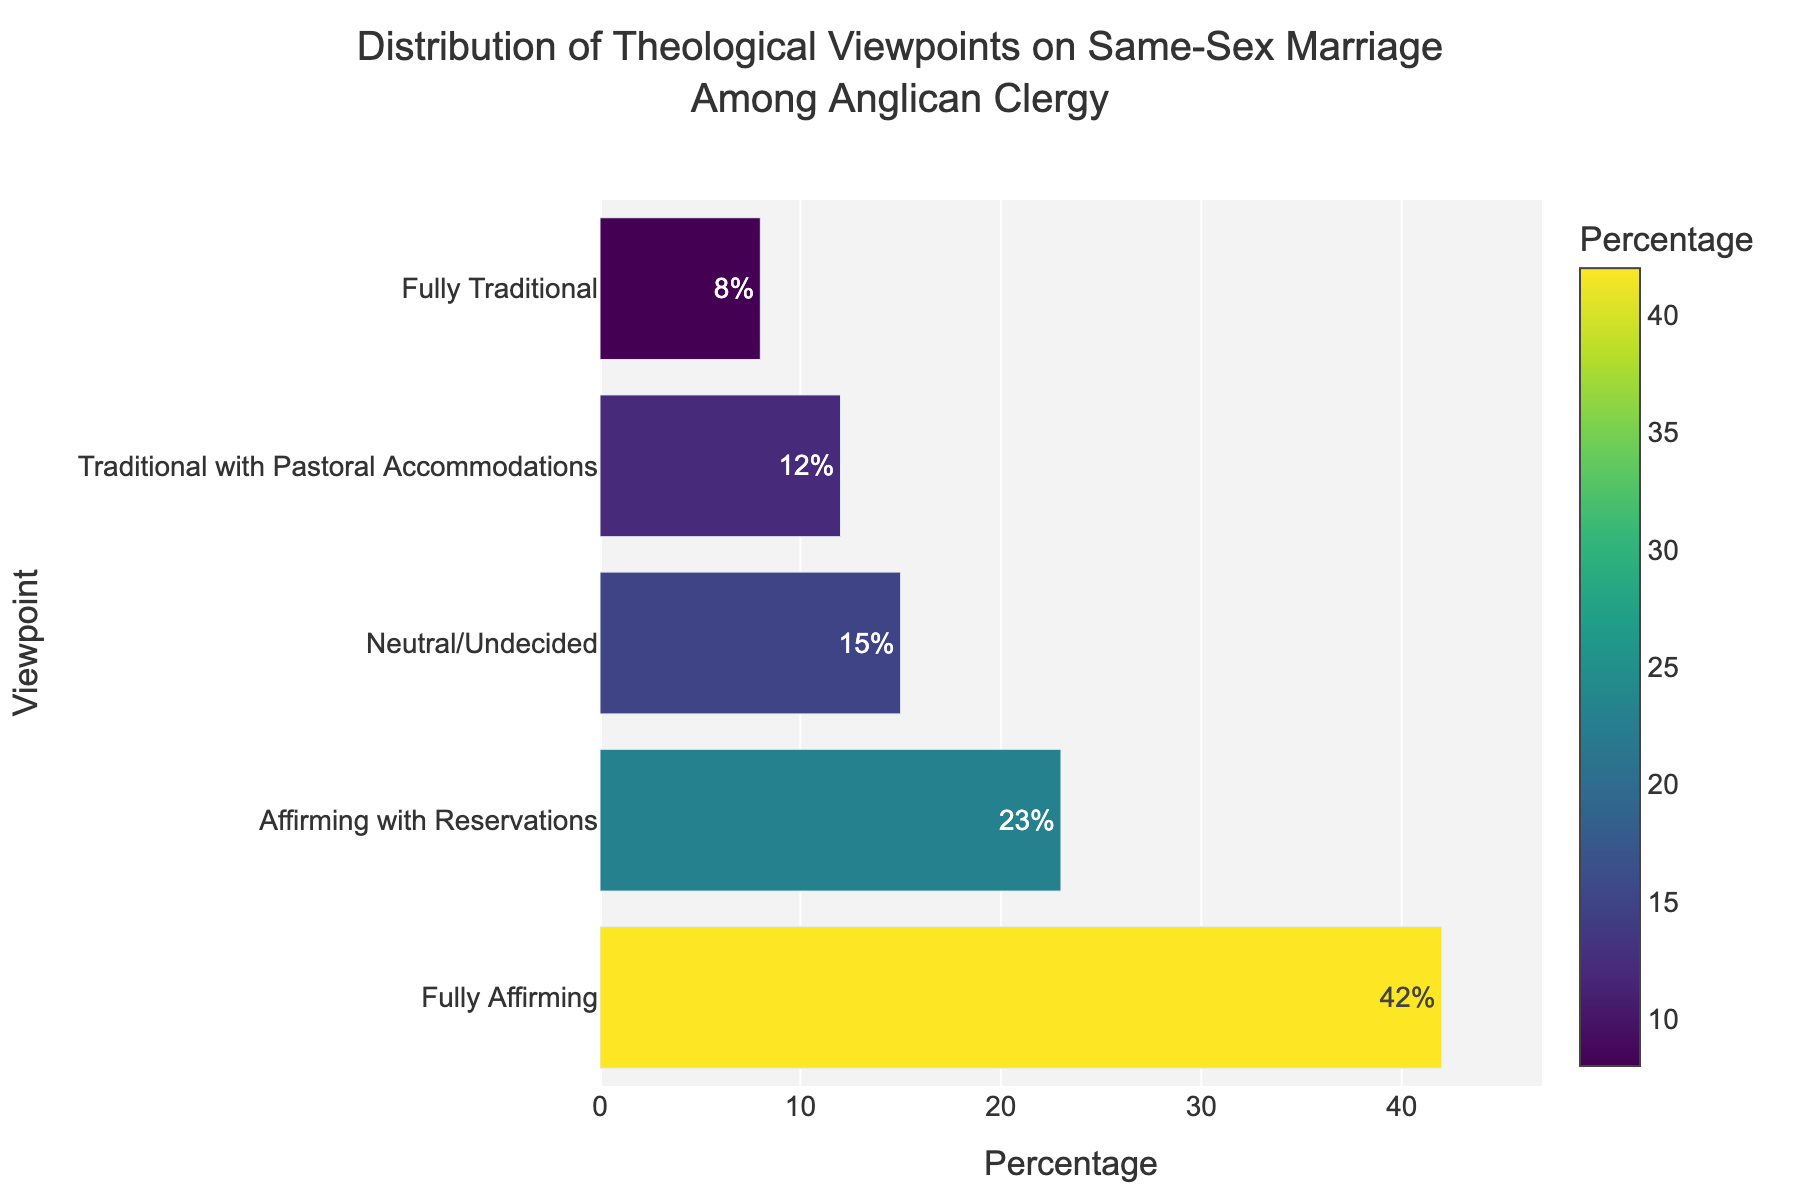Which viewpoint has the highest percentage? The bar chart shows that the "Fully Affirming" viewpoint has the longest bar and therefore the highest percentage.
Answer: Fully Affirming What is the difference in percentage between the "Fully Affirming" and "Fully Traditional" viewpoints? The percentage for "Fully Affirming" is 42% and for "Fully Traditional" is 8%. The difference is calculated as 42% - 8% = 34%.
Answer: 34% Which two viewpoints are closest in percentage? Observing the lengths of the bars, "Affirming with Reservations" and "Neutral/Undecided" viewpoints are closest, with 23% and 15%, respectively. The difference between them is 23% - 15% = 8%. The next closest difference is between "Traditional with Pastoral Accommodations" and "Fully Traditional", but that difference is 12% - 8% = 4%.
Answer: Affirming with Reservations and Neutral/Undecided What is the total percentage of clergy who are either "Fully Affirming" or "Fully Traditional"? To find the total, add the percentages for "Fully Affirming" (42%) and "Fully Traditional" (8%) viewpoints. The sum is 42% + 8% = 50%.
Answer: 50% Which viewpoint has a percentage that is greater than "Traditional with Pastoral Accommodations" but less than "Fully Affirming"? The bar chart shows the following percentages: "Traditional with Pastoral Accommodations" at 12% and "Fully Affirming" at 42%. The viewpoint that fits this range is "Neutral/Undecided" at 15%.
Answer: Neutral/Undecided What is the sum of percentages for viewpoints that are not fully traditional? Exclude the "Fully Traditional" percentage (8%) and sum the others: 42% ("Fully Affirming") + 23% ("Affirming with Reservations") + 15% ("Neutral/Undecided") + 12% ("Traditional with Pastoral Accommodations") = 92%.
Answer: 92% Which viewpoint has the smallest percentage? The shortest bar in the bar chart represents the "Fully Traditional" viewpoint, which has the smallest percentage of 8%.
Answer: Fully Traditional What is the percentage difference between "Affirming with Reservations" and "Neutral/Undecided"? The percentage for "Affirming with Reservations" is 23% and for "Neutral/Undecided" is 15%. The difference is calculated as 23% - 15% = 8%.
Answer: 8% How many viewpoints have a percentage higher than 20%? Observing the bar chart, there are two viewpoints with percentages higher than 20%: "Fully Affirming" (42%) and "Affirming with Reservations" (23%).
Answer: 2 